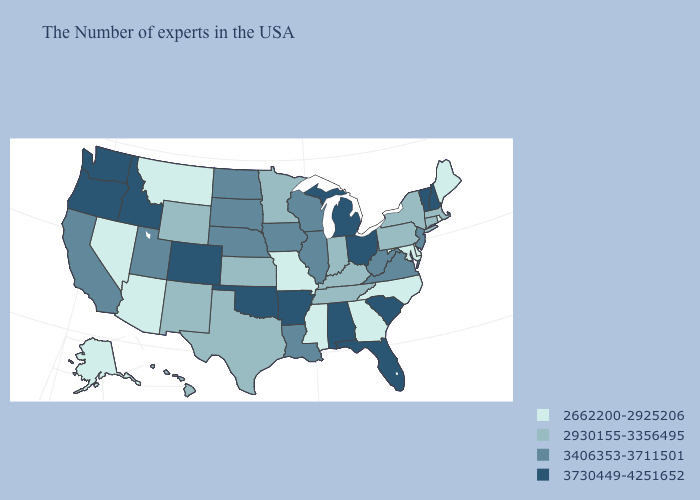Does Hawaii have a higher value than New Jersey?
Short answer required. No. Among the states that border Montana , does Idaho have the highest value?
Write a very short answer. Yes. Name the states that have a value in the range 3406353-3711501?
Write a very short answer. New Jersey, Virginia, West Virginia, Wisconsin, Illinois, Louisiana, Iowa, Nebraska, South Dakota, North Dakota, Utah, California. What is the value of North Dakota?
Concise answer only. 3406353-3711501. Among the states that border Oregon , does Washington have the lowest value?
Short answer required. No. Name the states that have a value in the range 3730449-4251652?
Be succinct. New Hampshire, Vermont, South Carolina, Ohio, Florida, Michigan, Alabama, Arkansas, Oklahoma, Colorado, Idaho, Washington, Oregon. What is the highest value in states that border Missouri?
Concise answer only. 3730449-4251652. Is the legend a continuous bar?
Short answer required. No. Among the states that border Utah , which have the highest value?
Be succinct. Colorado, Idaho. Name the states that have a value in the range 3406353-3711501?
Concise answer only. New Jersey, Virginia, West Virginia, Wisconsin, Illinois, Louisiana, Iowa, Nebraska, South Dakota, North Dakota, Utah, California. Name the states that have a value in the range 3406353-3711501?
Short answer required. New Jersey, Virginia, West Virginia, Wisconsin, Illinois, Louisiana, Iowa, Nebraska, South Dakota, North Dakota, Utah, California. Does Maine have the lowest value in the Northeast?
Quick response, please. Yes. Does West Virginia have the lowest value in the USA?
Quick response, please. No. Name the states that have a value in the range 3730449-4251652?
Quick response, please. New Hampshire, Vermont, South Carolina, Ohio, Florida, Michigan, Alabama, Arkansas, Oklahoma, Colorado, Idaho, Washington, Oregon. Does Michigan have the highest value in the MidWest?
Quick response, please. Yes. 